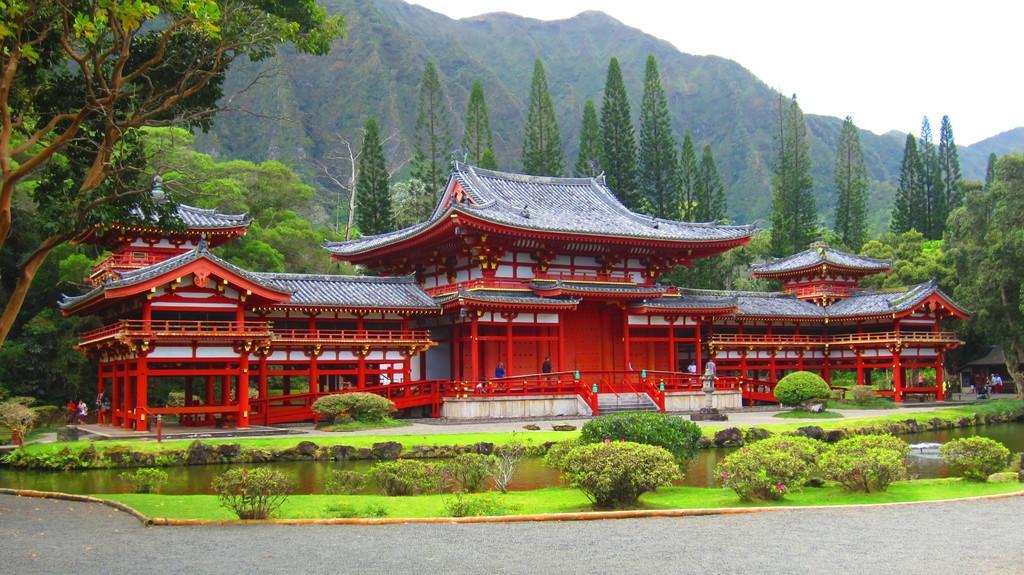In one or two sentences, can you explain what this image depicts? In the center of the image we can see house, stairs, some persons. In the background of the image we can see hills, trees. At the bottom of the image we can see some bushes, water. At the bottom of the image we can see the road. At the top of the image we can see the sky. 